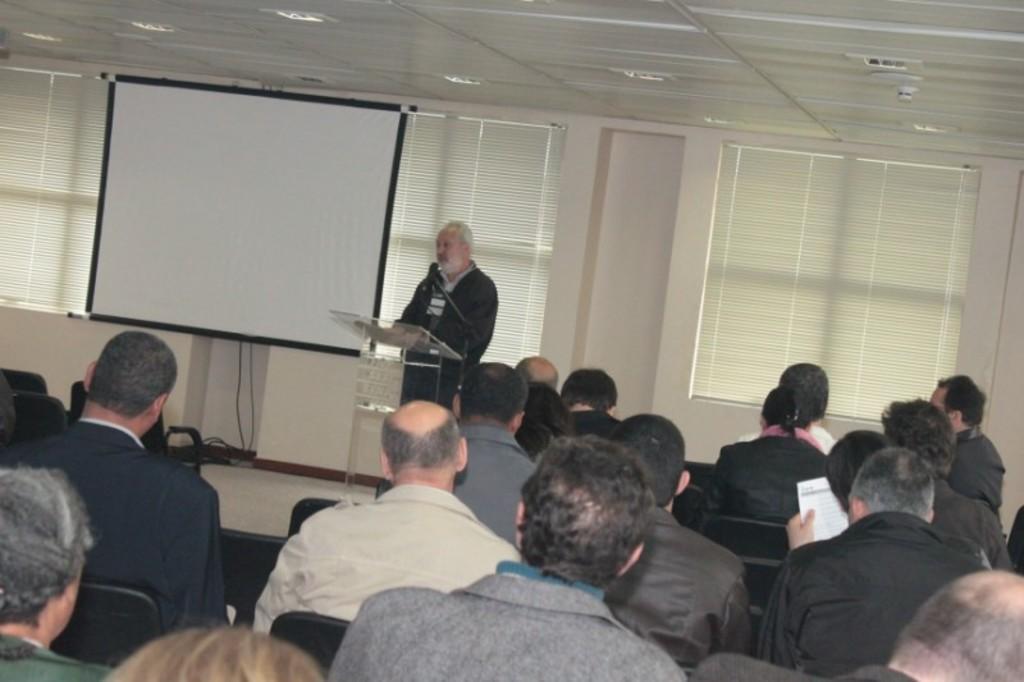Describe this image in one or two sentences. In the picture we can see many people are sitting in the chairs and front of them, we can see a man is talking in the microphone near the glass desk with some papers on it and behind her we can see the white color screen near the wall and to the wall we can see some windows and curtains to it and to the ceiling we can see some lights. 